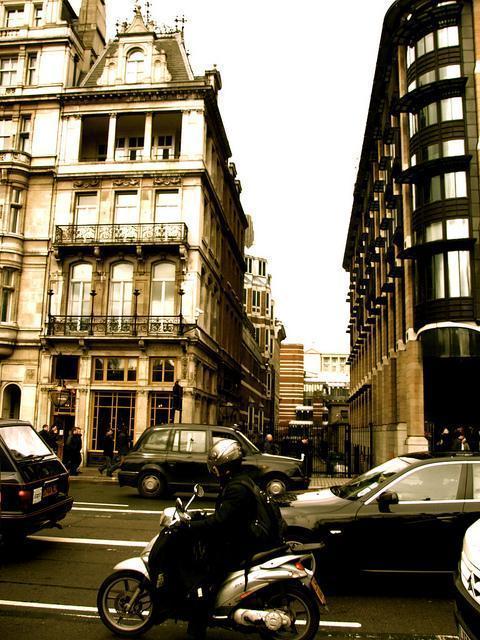How many cars are in the scene?
Give a very brief answer. 3. How many cars can you see?
Give a very brief answer. 4. How many elephants are holding their trunks up in the picture?
Give a very brief answer. 0. 